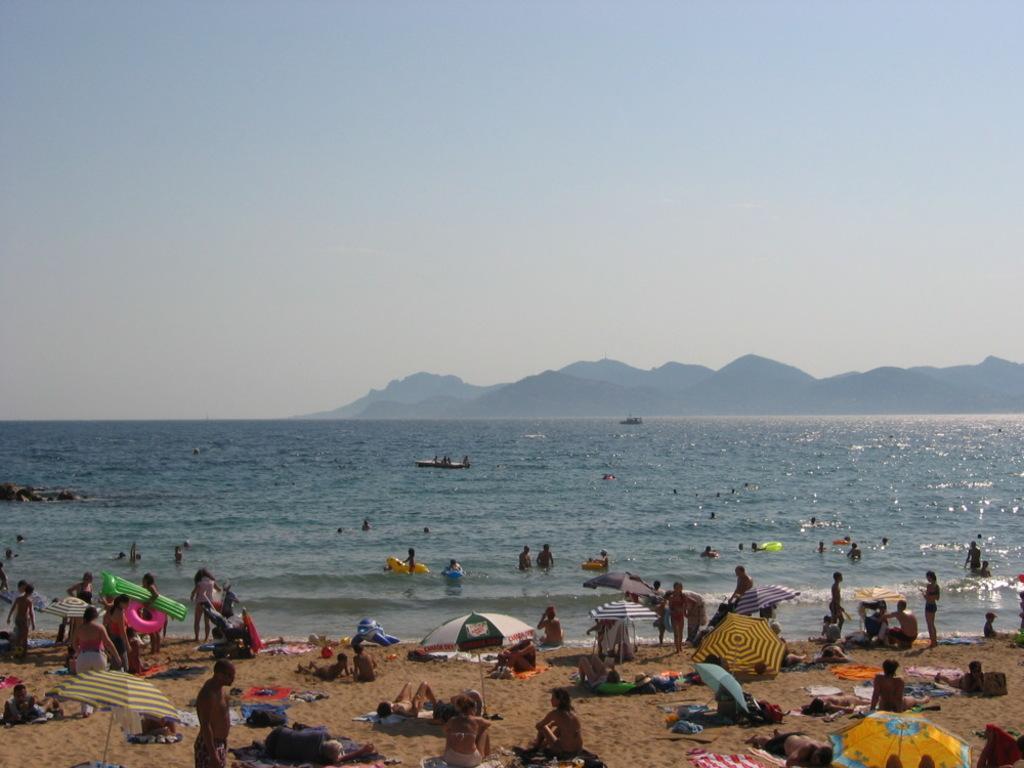Please provide a concise description of this image. This is the picture of a sea. In this image there are group of people, few are standing and few are sitting. At the back there are boats on the water and there are mountains. At the top there is sky. At the bottom there is sand. 